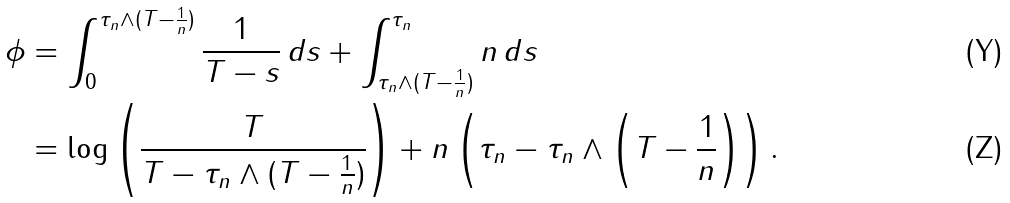Convert formula to latex. <formula><loc_0><loc_0><loc_500><loc_500>\phi & = \int _ { 0 } ^ { \tau _ { n } \wedge ( T - \frac { 1 } { n } ) } \frac { 1 } { T - s } \, d s + \int _ { \tau _ { n } \wedge ( T - \frac { 1 } { n } ) } ^ { \tau _ { n } } n \, d s \\ & = \log \left ( \frac { T } { T - \tau _ { n } \wedge ( T - \frac { 1 } { n } ) } \right ) + n \left ( \tau _ { n } - \tau _ { n } \wedge \left ( T - \frac { 1 } { n } \right ) \right ) .</formula> 